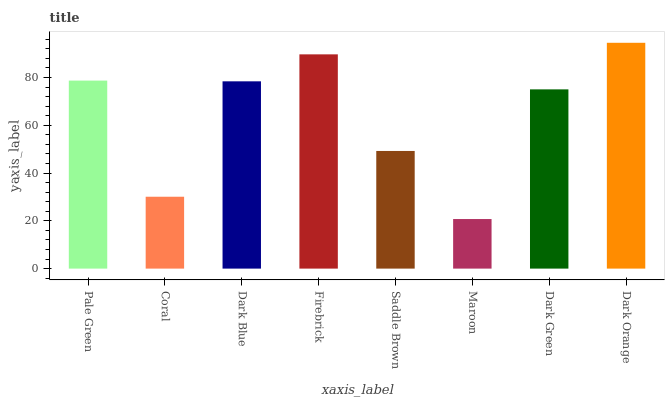Is Maroon the minimum?
Answer yes or no. Yes. Is Dark Orange the maximum?
Answer yes or no. Yes. Is Coral the minimum?
Answer yes or no. No. Is Coral the maximum?
Answer yes or no. No. Is Pale Green greater than Coral?
Answer yes or no. Yes. Is Coral less than Pale Green?
Answer yes or no. Yes. Is Coral greater than Pale Green?
Answer yes or no. No. Is Pale Green less than Coral?
Answer yes or no. No. Is Dark Blue the high median?
Answer yes or no. Yes. Is Dark Green the low median?
Answer yes or no. Yes. Is Pale Green the high median?
Answer yes or no. No. Is Saddle Brown the low median?
Answer yes or no. No. 